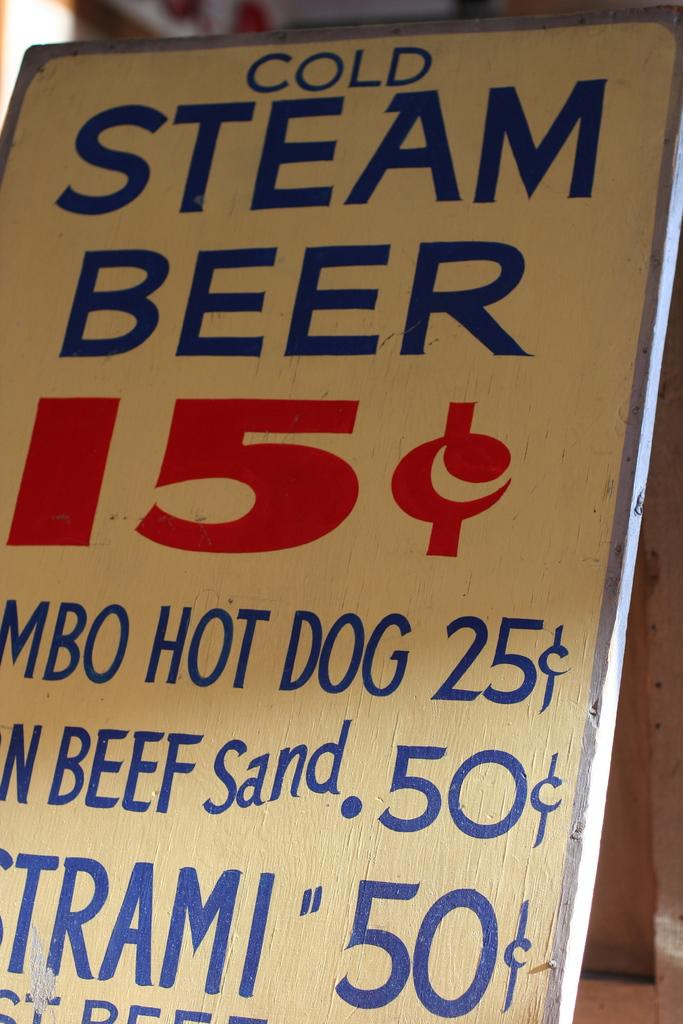<image>
Provide a brief description of the given image. A sign for Cold Steam Beer and some food choices below it. 